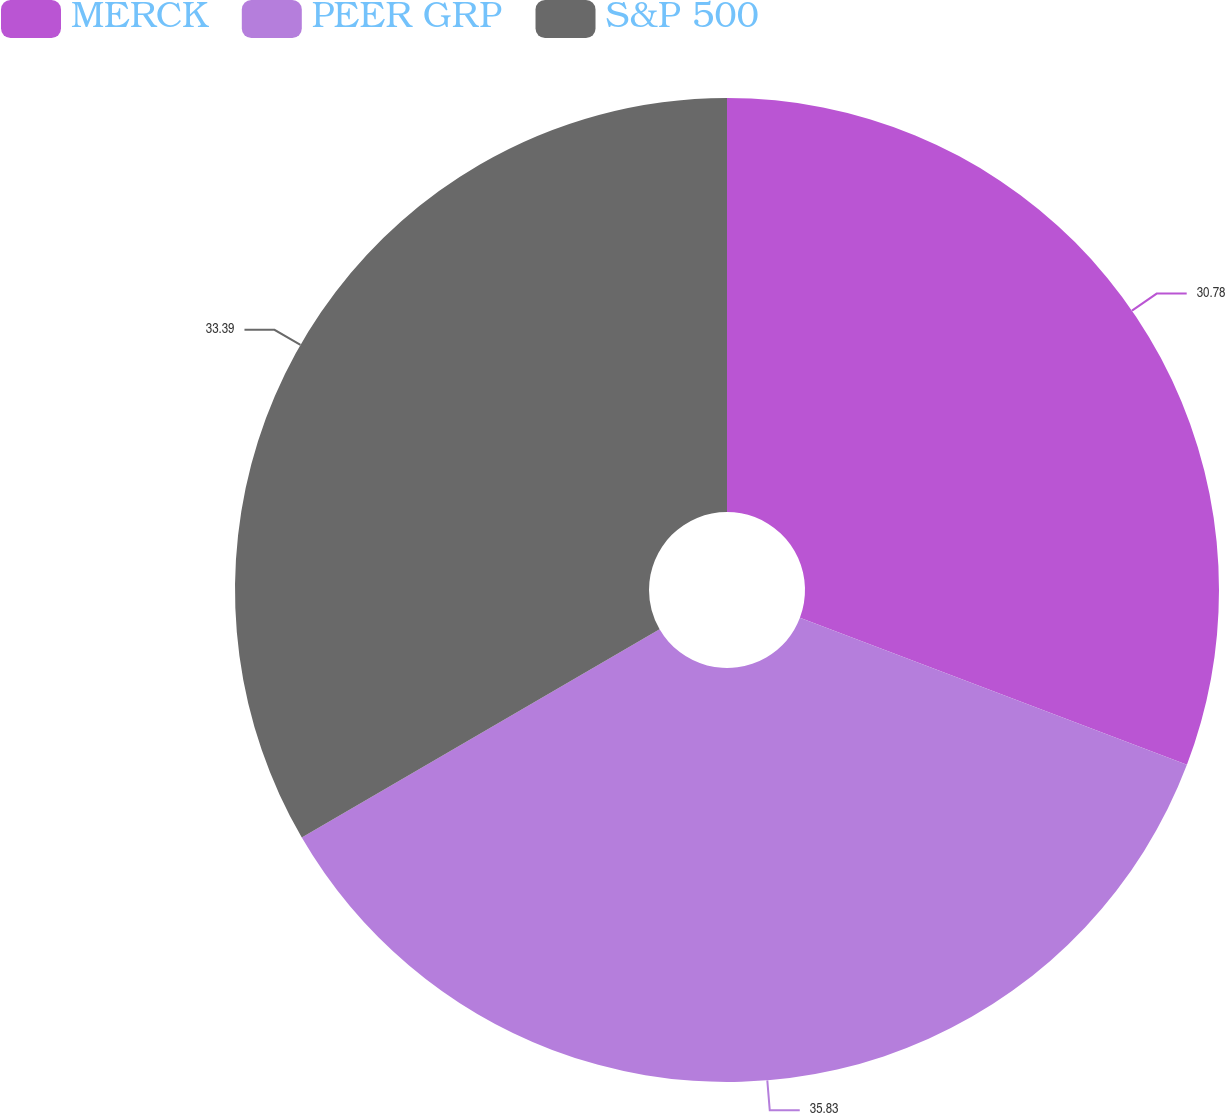Convert chart. <chart><loc_0><loc_0><loc_500><loc_500><pie_chart><fcel>MERCK<fcel>PEER GRP<fcel>S&P 500<nl><fcel>30.78%<fcel>35.83%<fcel>33.39%<nl></chart> 